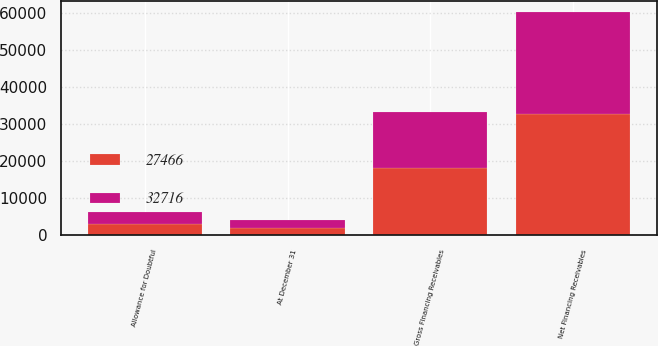Convert chart to OTSL. <chart><loc_0><loc_0><loc_500><loc_500><stacked_bar_chart><ecel><fcel>At December 31<fcel>Gross Financing Receivables<fcel>Allowance for Doubtful<fcel>Net Financing Receivables<nl><fcel>27466<fcel>2016<fcel>18178<fcel>3157<fcel>32716<nl><fcel>32716<fcel>2015<fcel>15080<fcel>3288<fcel>27466<nl></chart> 